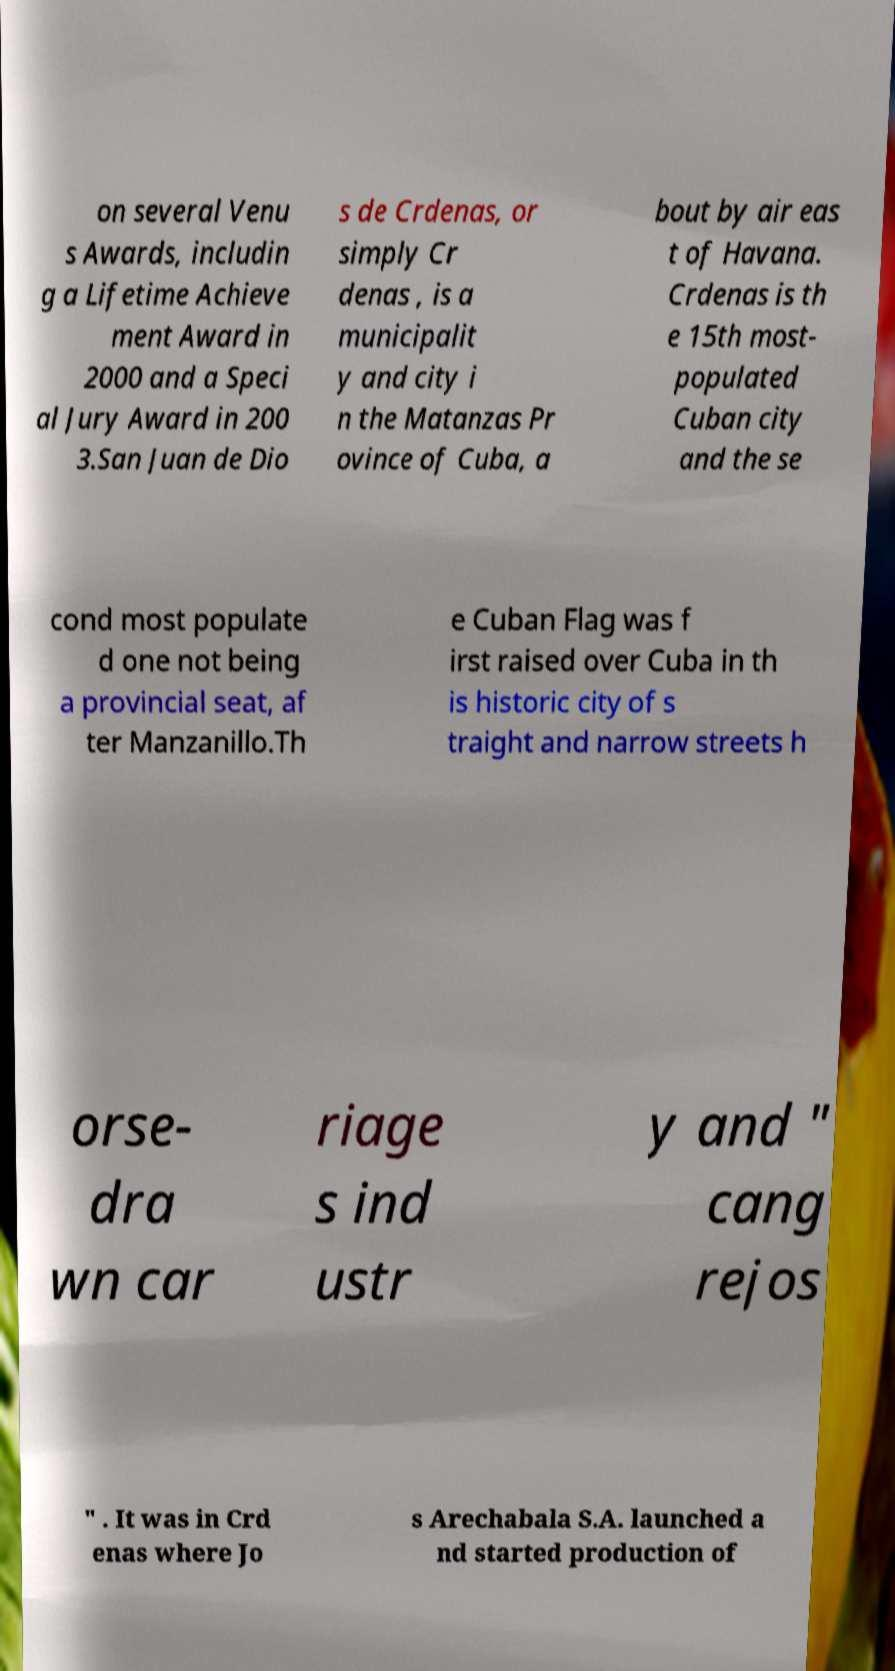There's text embedded in this image that I need extracted. Can you transcribe it verbatim? on several Venu s Awards, includin g a Lifetime Achieve ment Award in 2000 and a Speci al Jury Award in 200 3.San Juan de Dio s de Crdenas, or simply Cr denas , is a municipalit y and city i n the Matanzas Pr ovince of Cuba, a bout by air eas t of Havana. Crdenas is th e 15th most- populated Cuban city and the se cond most populate d one not being a provincial seat, af ter Manzanillo.Th e Cuban Flag was f irst raised over Cuba in th is historic city of s traight and narrow streets h orse- dra wn car riage s ind ustr y and " cang rejos " . It was in Crd enas where Jo s Arechabala S.A. launched a nd started production of 